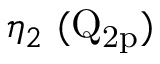<formula> <loc_0><loc_0><loc_500><loc_500>\eta _ { 2 } ( Q _ { 2 p } )</formula> 